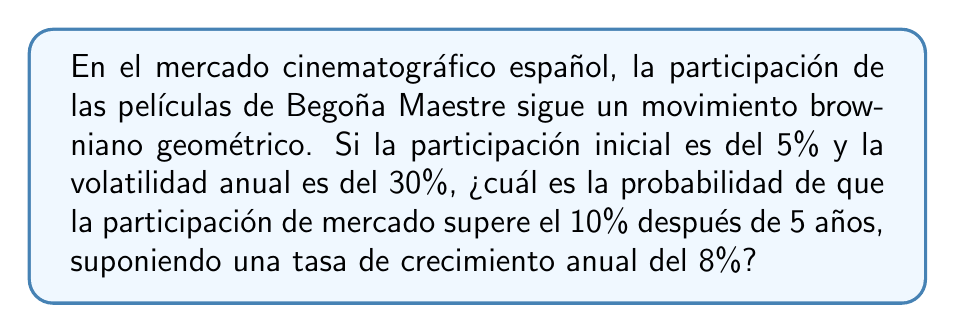Help me with this question. Para resolver este problema, seguiremos estos pasos:

1) El movimiento browniano geométrico se describe mediante la ecuación:

   $$S_t = S_0 \exp\left(\left(\mu - \frac{\sigma^2}{2}\right)t + \sigma W_t\right)$$

   Donde:
   $S_t$ es la participación de mercado en el tiempo $t$
   $S_0$ es la participación inicial
   $\mu$ es la tasa de crecimiento anual
   $\sigma$ es la volatilidad anual
   $W_t$ es un movimiento browniano estándar

2) En este caso:
   $S_0 = 5\%$
   $\mu = 8\% = 0.08$
   $\sigma = 30\% = 0.3$
   $t = 5$ años

3) Queremos calcular $P(S_5 > 10\%)$. Esto es equivalente a:

   $$P\left(\ln(S_5) > \ln(10\%)\right)$$

4) Sabemos que $\ln(S_t)$ sigue una distribución normal con:

   Media: $\ln(S_0) + (\mu - \frac{\sigma^2}{2})t$
   Varianza: $\sigma^2 t$

5) Calculamos estos valores:

   Media = $\ln(0.05) + (0.08 - \frac{0.3^2}{2})5 = -2.9957 + 0.1750 = -2.8207$
   Varianza = $0.3^2 \cdot 5 = 0.45$

6) Ahora podemos estandarizar:

   $$Z = \frac{\ln(10\%) - (-2.8207)}{\sqrt{0.45}} = \frac{-2.3026 - (-2.8207)}{\sqrt{0.45}} = 0.7726$$

7) La probabilidad buscada es $P(Z > 0.7726)$, que es igual a $1 - \Phi(0.7726)$, donde $\Phi$ es la función de distribución acumulativa de la normal estándar.

8) Usando una calculadora o tabla de la distribución normal, encontramos:

   $1 - \Phi(0.7726) \approx 0.2199$

Por lo tanto, la probabilidad de que la participación de mercado supere el 10% después de 5 años es aproximadamente 0.2199 o 21.99%.
Answer: 21.99% 